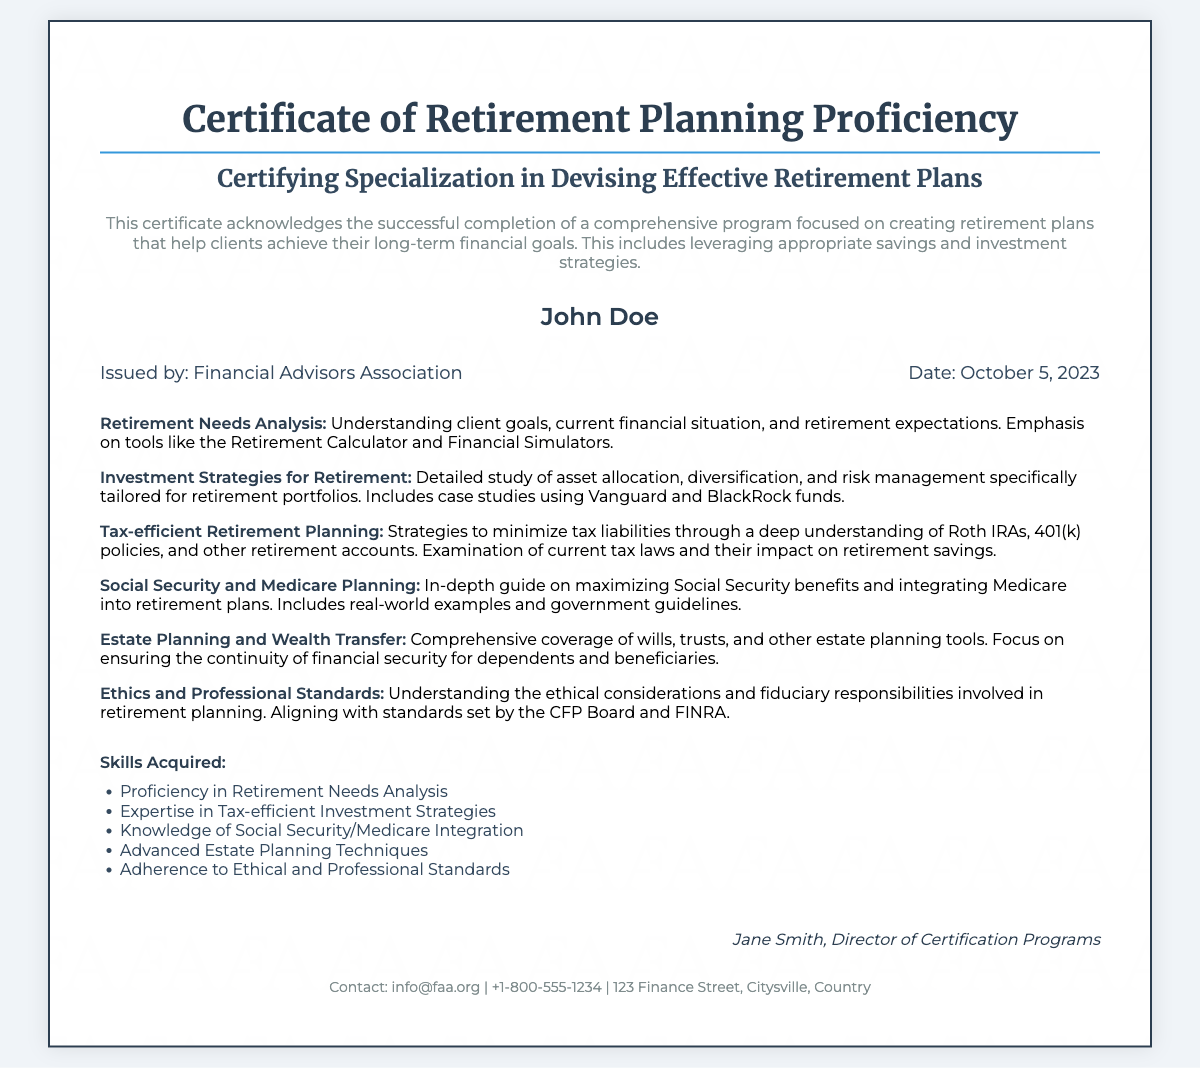What is the title of the certificate? The title appears prominently at the top of the document, which is "Certificate of Retirement Planning Proficiency."
Answer: Certificate of Retirement Planning Proficiency Who is the recipient of the certificate? The name of the recipient is clearly stated in the certificate section, which identifies the person awarded this certificate.
Answer: John Doe When was the certificate issued? The date of issuance is displayed in the details section, indicating when the certification was conferred.
Answer: October 5, 2023 What organization issued the certificate? The issuer of the certificate is mentioned alongside the date, indicating the authority behind this certification.
Answer: Financial Advisors Association What is one of the modules covered in the course? The document lists various modules in a specific section; one of them summarizes a key area of study related to retirement planning.
Answer: Retirement Needs Analysis What is a skill acquired through this certification? The skills acquired are listed clearly; one of the skills reflects the knowledge gained from the program.
Answer: Proficiency in Retirement Needs Analysis What is one focus area of the "Tax-efficient Retirement Planning" module? This module description indicates a specific strategy taught in the course aimed at minimizing tax liabilities.
Answer: Roth IRAs Who signed the certificate? The signature section at the bottom identifies the individual responsible for certifying the completion of the program.
Answer: Jane Smith 